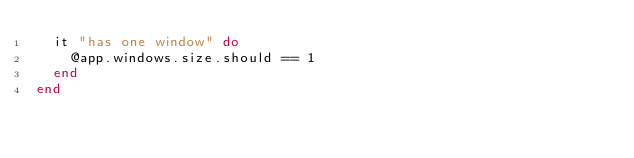<code> <loc_0><loc_0><loc_500><loc_500><_Ruby_>  it "has one window" do
    @app.windows.size.should == 1
  end
end
</code> 